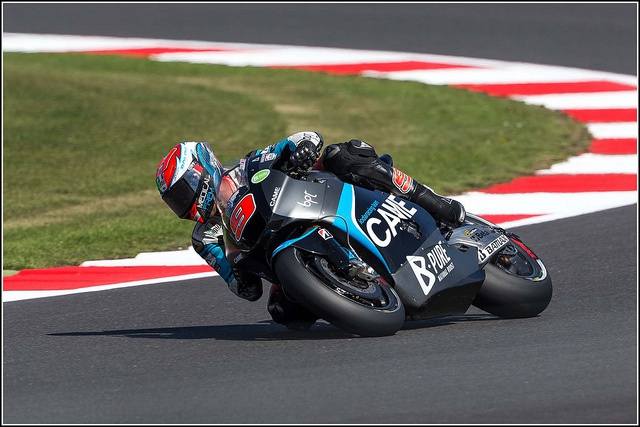Describe the objects in this image and their specific colors. I can see motorcycle in black, gray, navy, and white tones and people in black, gray, lightgray, and navy tones in this image. 